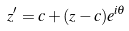<formula> <loc_0><loc_0><loc_500><loc_500>z ^ { \prime } = c + ( z - c ) e ^ { i \theta }</formula> 